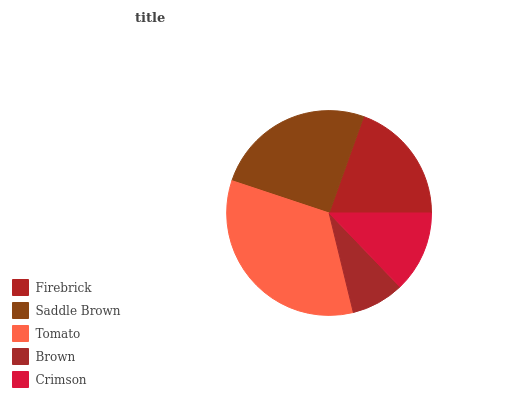Is Brown the minimum?
Answer yes or no. Yes. Is Tomato the maximum?
Answer yes or no. Yes. Is Saddle Brown the minimum?
Answer yes or no. No. Is Saddle Brown the maximum?
Answer yes or no. No. Is Saddle Brown greater than Firebrick?
Answer yes or no. Yes. Is Firebrick less than Saddle Brown?
Answer yes or no. Yes. Is Firebrick greater than Saddle Brown?
Answer yes or no. No. Is Saddle Brown less than Firebrick?
Answer yes or no. No. Is Firebrick the high median?
Answer yes or no. Yes. Is Firebrick the low median?
Answer yes or no. Yes. Is Brown the high median?
Answer yes or no. No. Is Brown the low median?
Answer yes or no. No. 